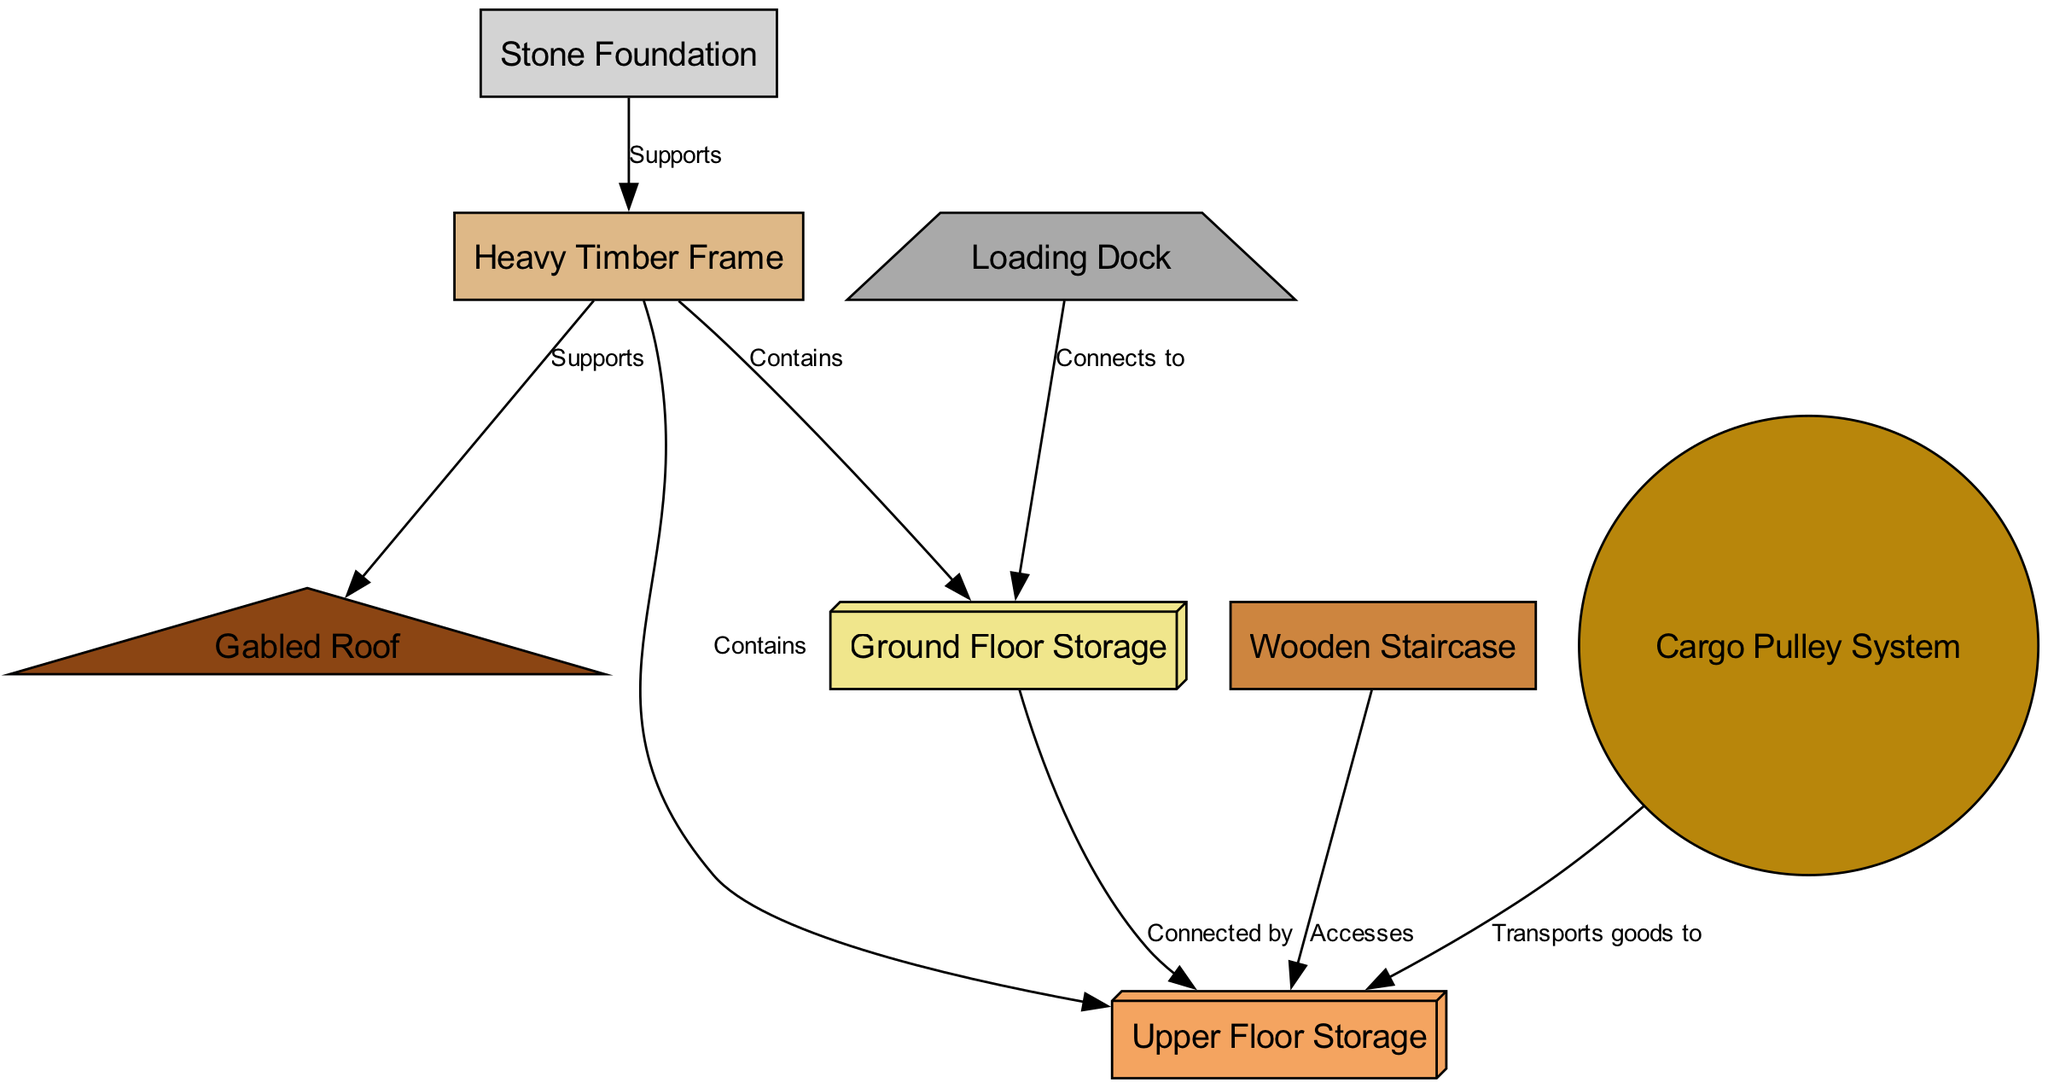What is the material of the foundation? The diagram indicates that the foundation is represented as "Stone Foundation," which is labeled in the diagram.
Answer: Stone Foundation How many floors are stored in the warehouse? The diagram shows two distinct storage types: "Ground Floor Storage" and "Upper Floor Storage," indicating there are two floors.
Answer: Two What connects the loading dock to the ground floor? The connection is explicitly labeled as "Connects to" in the edge originating from "Loading Dock" and pointing to "Ground Floor Storage."
Answer: Ground Floor Storage What structural element supports the roof? The edge labeled "Supports" connects the "Timber Frame" to the "Roof," indicating that the timber frame provides the necessary support.
Answer: Heavy Timber Frame Which system transports goods to the upper floor? The edge from the "Cargo Pulley System" to the "Upper Floor Storage" is labeled "Transports goods to," showing this functionality.
Answer: Cargo Pulley System How is access to the upper floor achieved? The diagram specifies that the "Wooden Staircase" accesses the "Upper Floor Storage," reflecting the method of access.
Answer: Wooden Staircase What is the function of the staircase in relation to the upper floor? The edge from "Staircase" to "Upper Floor Storage" is marked "Accesses," indicating the staircase's role in reaching the upper floor.
Answer: Accesses How many structural elements are present in the diagram? The diagram includes eight nodes representing different structural elements, including the foundation, timber frame, roof, loading dock, ground floor, upper floor, staircase, and pulley system.
Answer: Eight What type of roof is present in the warehouse design? The diagram describes the roof as a "Gabled Roof," which is explicitly labeled in the diagram.
Answer: Gabled Roof 